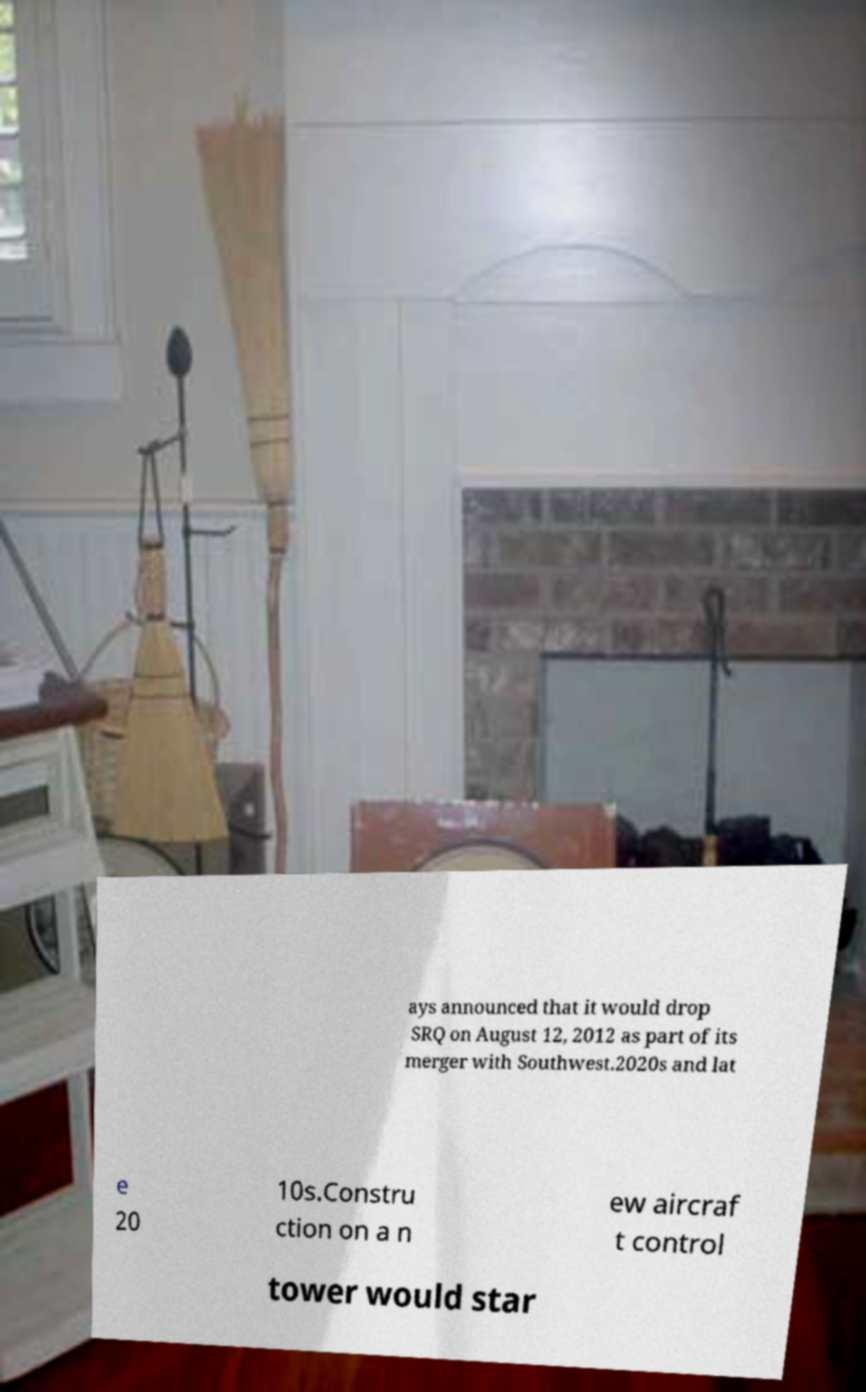Could you assist in decoding the text presented in this image and type it out clearly? ays announced that it would drop SRQ on August 12, 2012 as part of its merger with Southwest.2020s and lat e 20 10s.Constru ction on a n ew aircraf t control tower would star 